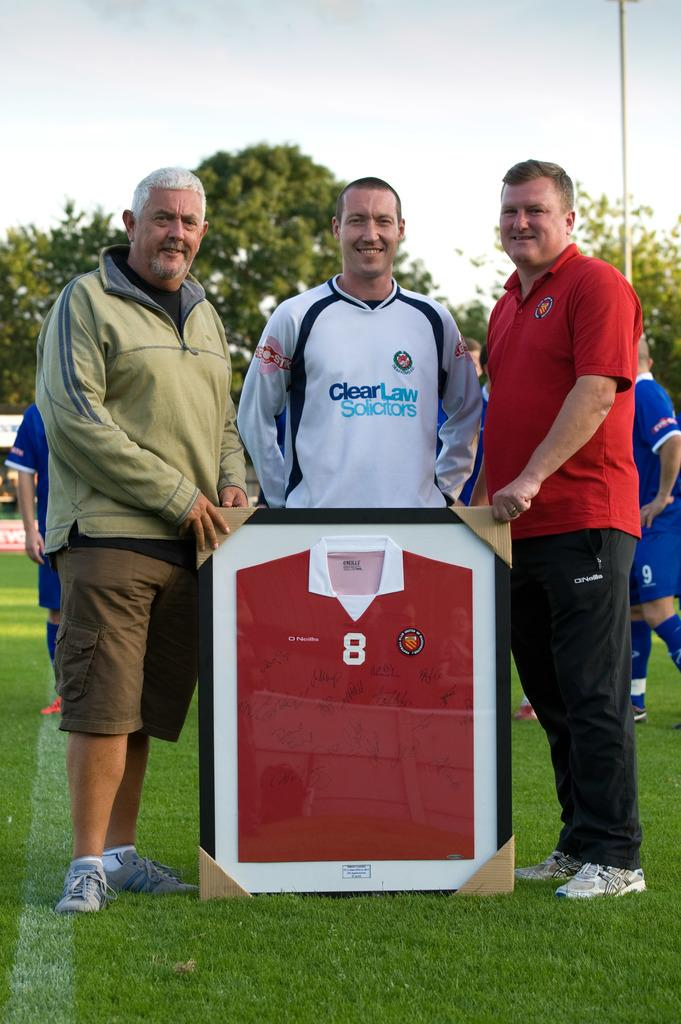How many men are in the image? There are three men standing in the image. What are the men wearing? The men are wearing clothes and shoes. What can be seen in the background of the image? There are people walking in the background of the image. What type of natural environment is visible in the image? Grass, trees, and the sky are visible in the image. What word is being spelled out by the cherries in the image? There are no cherries present in the image, so no word can be spelled out by them. What type of music is being played by the band in the image? There is no band present in the image, so no music can be heard or played. 